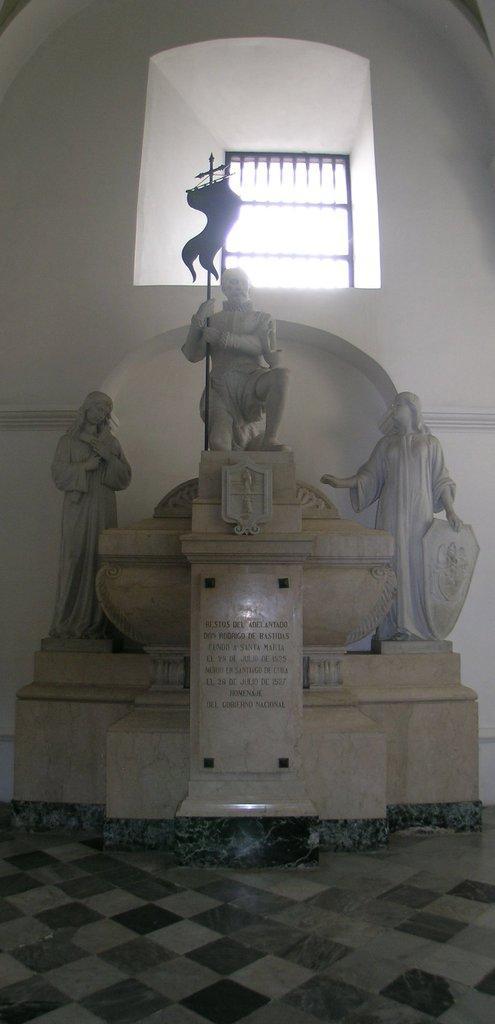In one or two sentences, can you explain what this image depicts? In this picture I can see there are statues and the middle statue is holding the flag and there is a window in the backdrop and there is a wall. 